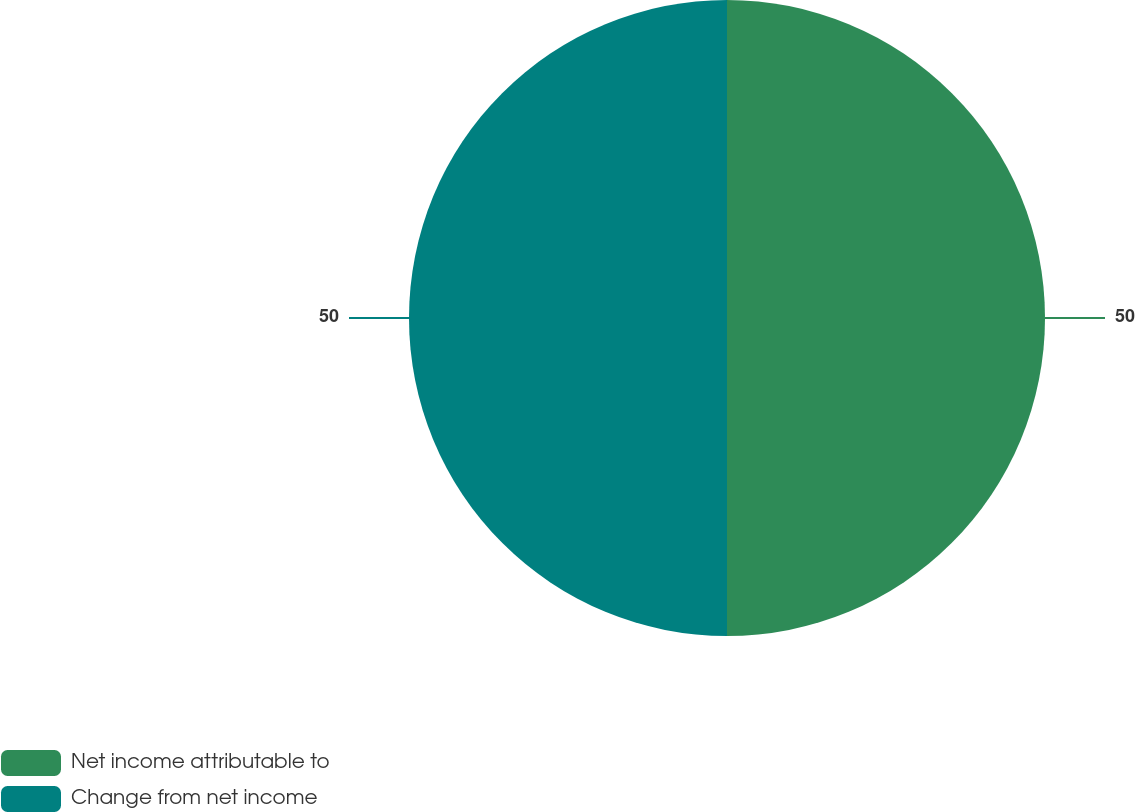Convert chart. <chart><loc_0><loc_0><loc_500><loc_500><pie_chart><fcel>Net income attributable to<fcel>Change from net income<nl><fcel>50.0%<fcel>50.0%<nl></chart> 